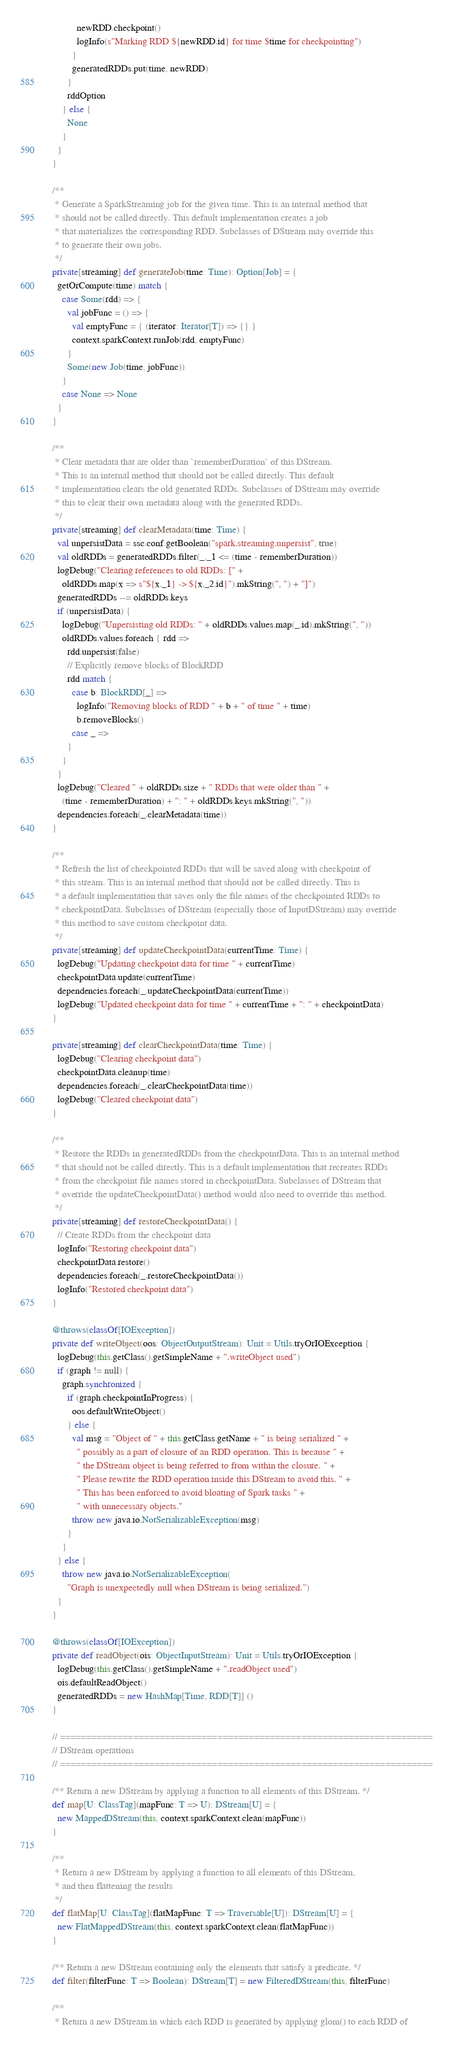<code> <loc_0><loc_0><loc_500><loc_500><_Scala_>            newRDD.checkpoint()
            logInfo(s"Marking RDD ${newRDD.id} for time $time for checkpointing")
          }
          generatedRDDs.put(time, newRDD)
        }
        rddOption
      } else {
        None
      }
    }
  }

  /**
   * Generate a SparkStreaming job for the given time. This is an internal method that
   * should not be called directly. This default implementation creates a job
   * that materializes the corresponding RDD. Subclasses of DStream may override this
   * to generate their own jobs.
   */
  private[streaming] def generateJob(time: Time): Option[Job] = {
    getOrCompute(time) match {
      case Some(rdd) => {
        val jobFunc = () => {
          val emptyFunc = { (iterator: Iterator[T]) => {} }
          context.sparkContext.runJob(rdd, emptyFunc)
        }
        Some(new Job(time, jobFunc))
      }
      case None => None
    }
  }

  /**
   * Clear metadata that are older than `rememberDuration` of this DStream.
   * This is an internal method that should not be called directly. This default
   * implementation clears the old generated RDDs. Subclasses of DStream may override
   * this to clear their own metadata along with the generated RDDs.
   */
  private[streaming] def clearMetadata(time: Time) {
    val unpersistData = ssc.conf.getBoolean("spark.streaming.unpersist", true)
    val oldRDDs = generatedRDDs.filter(_._1 <= (time - rememberDuration))
    logDebug("Clearing references to old RDDs: [" +
      oldRDDs.map(x => s"${x._1} -> ${x._2.id}").mkString(", ") + "]")
    generatedRDDs --= oldRDDs.keys
    if (unpersistData) {
      logDebug("Unpersisting old RDDs: " + oldRDDs.values.map(_.id).mkString(", "))
      oldRDDs.values.foreach { rdd =>
        rdd.unpersist(false)
        // Explicitly remove blocks of BlockRDD
        rdd match {
          case b: BlockRDD[_] =>
            logInfo("Removing blocks of RDD " + b + " of time " + time)
            b.removeBlocks()
          case _ =>
        }
      }
    }
    logDebug("Cleared " + oldRDDs.size + " RDDs that were older than " +
      (time - rememberDuration) + ": " + oldRDDs.keys.mkString(", "))
    dependencies.foreach(_.clearMetadata(time))
  }

  /**
   * Refresh the list of checkpointed RDDs that will be saved along with checkpoint of
   * this stream. This is an internal method that should not be called directly. This is
   * a default implementation that saves only the file names of the checkpointed RDDs to
   * checkpointData. Subclasses of DStream (especially those of InputDStream) may override
   * this method to save custom checkpoint data.
   */
  private[streaming] def updateCheckpointData(currentTime: Time) {
    logDebug("Updating checkpoint data for time " + currentTime)
    checkpointData.update(currentTime)
    dependencies.foreach(_.updateCheckpointData(currentTime))
    logDebug("Updated checkpoint data for time " + currentTime + ": " + checkpointData)
  }

  private[streaming] def clearCheckpointData(time: Time) {
    logDebug("Clearing checkpoint data")
    checkpointData.cleanup(time)
    dependencies.foreach(_.clearCheckpointData(time))
    logDebug("Cleared checkpoint data")
  }

  /**
   * Restore the RDDs in generatedRDDs from the checkpointData. This is an internal method
   * that should not be called directly. This is a default implementation that recreates RDDs
   * from the checkpoint file names stored in checkpointData. Subclasses of DStream that
   * override the updateCheckpointData() method would also need to override this method.
   */
  private[streaming] def restoreCheckpointData() {
    // Create RDDs from the checkpoint data
    logInfo("Restoring checkpoint data")
    checkpointData.restore()
    dependencies.foreach(_.restoreCheckpointData())
    logInfo("Restored checkpoint data")
  }

  @throws(classOf[IOException])
  private def writeObject(oos: ObjectOutputStream): Unit = Utils.tryOrIOException {
    logDebug(this.getClass().getSimpleName + ".writeObject used")
    if (graph != null) {
      graph.synchronized {
        if (graph.checkpointInProgress) {
          oos.defaultWriteObject()
        } else {
          val msg = "Object of " + this.getClass.getName + " is being serialized " +
            " possibly as a part of closure of an RDD operation. This is because " +
            " the DStream object is being referred to from within the closure. " +
            " Please rewrite the RDD operation inside this DStream to avoid this. " +
            " This has been enforced to avoid bloating of Spark tasks " +
            " with unnecessary objects."
          throw new java.io.NotSerializableException(msg)
        }
      }
    } else {
      throw new java.io.NotSerializableException(
        "Graph is unexpectedly null when DStream is being serialized.")
    }
  }

  @throws(classOf[IOException])
  private def readObject(ois: ObjectInputStream): Unit = Utils.tryOrIOException {
    logDebug(this.getClass().getSimpleName + ".readObject used")
    ois.defaultReadObject()
    generatedRDDs = new HashMap[Time, RDD[T]] ()
  }

  // =======================================================================
  // DStream operations
  // =======================================================================

  /** Return a new DStream by applying a function to all elements of this DStream. */
  def map[U: ClassTag](mapFunc: T => U): DStream[U] = {
    new MappedDStream(this, context.sparkContext.clean(mapFunc))
  }

  /**
   * Return a new DStream by applying a function to all elements of this DStream,
   * and then flattening the results
   */
  def flatMap[U: ClassTag](flatMapFunc: T => Traversable[U]): DStream[U] = {
    new FlatMappedDStream(this, context.sparkContext.clean(flatMapFunc))
  }

  /** Return a new DStream containing only the elements that satisfy a predicate. */
  def filter(filterFunc: T => Boolean): DStream[T] = new FilteredDStream(this, filterFunc)

  /**
   * Return a new DStream in which each RDD is generated by applying glom() to each RDD of</code> 